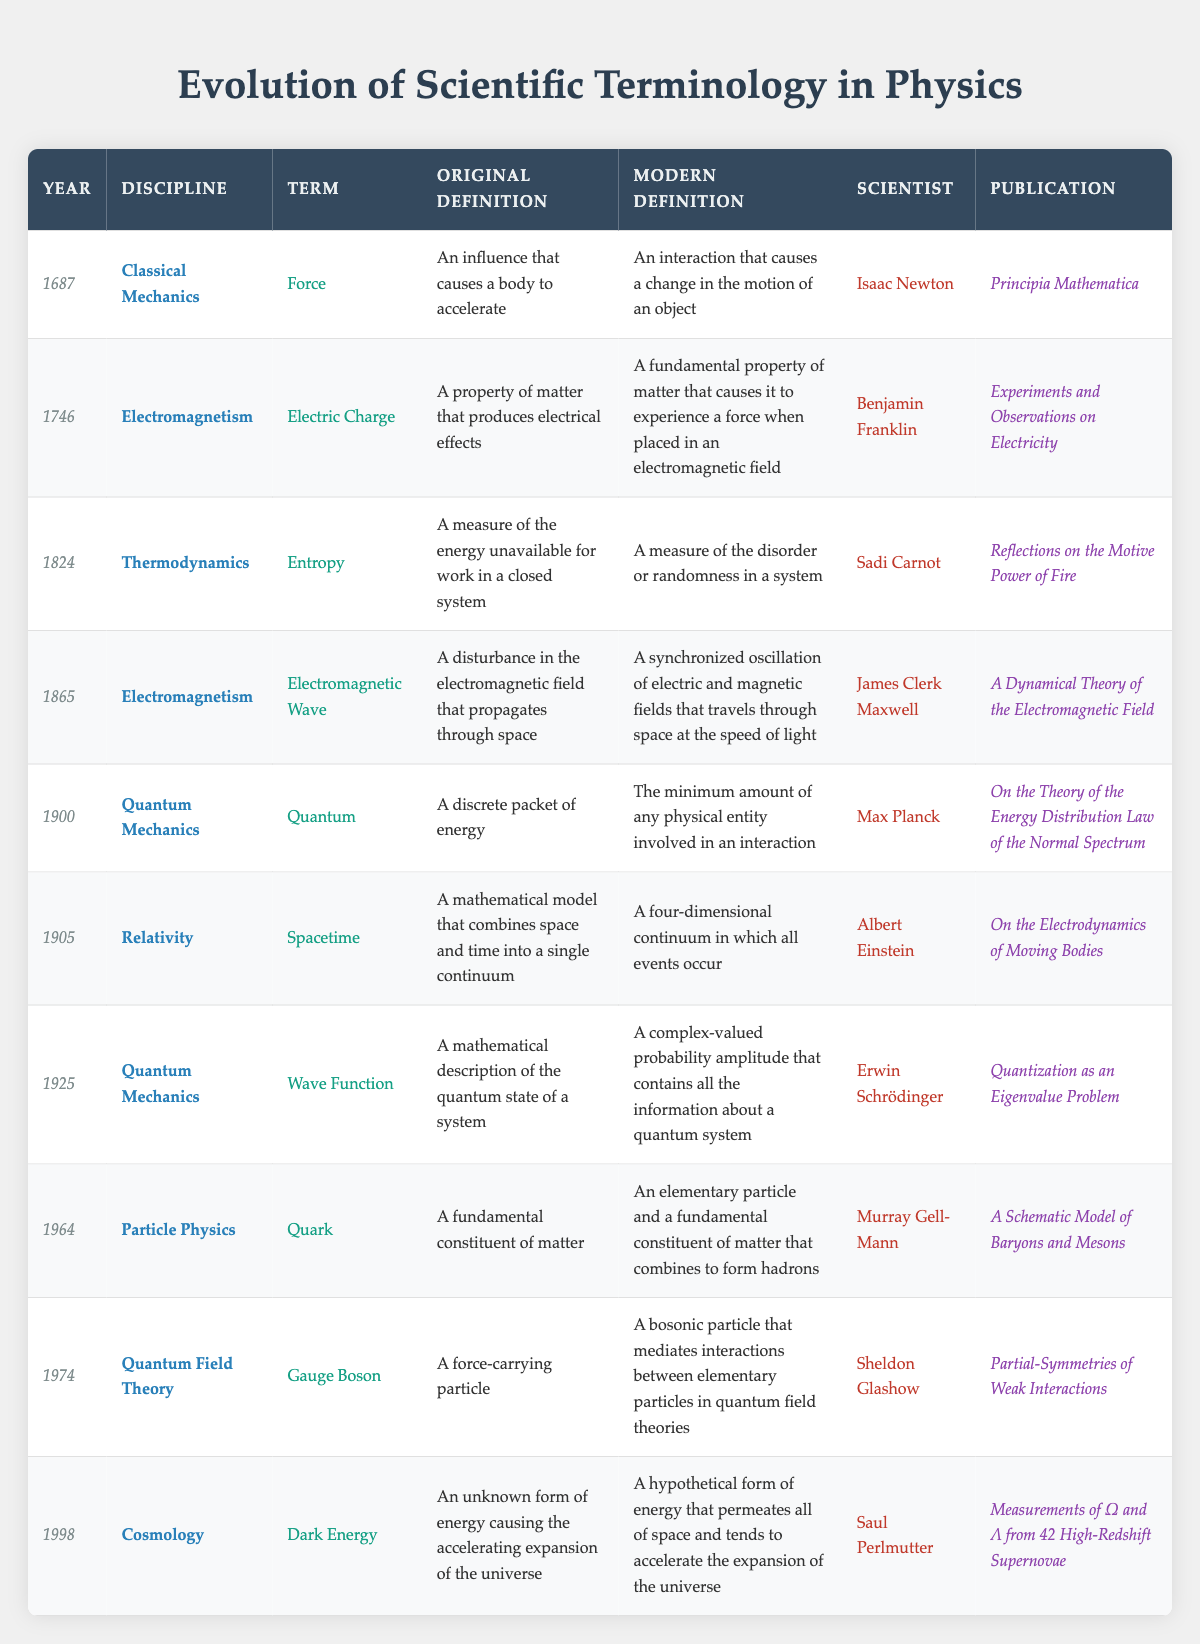What was the original definition of "Force"? The definition of "Force" can be found in the table under the row for the year 1687 and the discipline of Classical Mechanics, which states it as "An influence that causes a body to accelerate".
Answer: An influence that causes a body to accelerate Which scientist published the term "Quantum"? By locating the row for the year 1900 and the discipline of Quantum Mechanics, we identify that Max Planck is the scientist associated with the term "Quantum".
Answer: Max Planck How many terms were defined before the year 1900? To find out how many terms were defined before 1900, we can count the rows with years less than 1900. There are six entries (1687, 1746, 1824, 1865, 1900) before it.
Answer: 5 What is the modern definition of "Dark Energy"? The row corresponding to the year 1998 and the discipline of Cosmology provides the modern definition of "Dark Energy", which states it as "A hypothetical form of energy that permeates all of space and tends to accelerate the expansion of the universe".
Answer: A hypothetical form of energy that permeates all of space and tends to accelerate the expansion of the universe Which term has the most recent definition and who is the associated scientist? The most recent term based on the year column is "Dark Energy" from 1998, associated with Saul Perlmutter.
Answer: Dark Energy, Saul Perlmutter Did Sadi Carnot publish a work related to Quantum Mechanics? To check this, we look at the discipline published by Sadi Carnot, which is listed under Thermodynamics, not Quantum Mechanics. Therefore, the answer is no.
Answer: No What is the average year of publication for the terms listed in Particle Physics and Quantum Field Theory? The years for Particle Physics (Quark, 1964) and Quantum Field Theory (Gauge Boson, 1974) are 1964 and 1974, respectively. Adding these gives 3948, and dividing by 2 yields an average year of 1974.
Answer: 1974 How does the original definition of "Electromagnetic Wave" differ from its modern definition? By examining the row for the term "Electromagnetic Wave" in the table, we see the original definition describes it as "A disturbance in the electromagnetic field that propagates through space", while the modern definition elaborates to "A synchronized oscillation of electric and magnetic fields that travels through space at the speed of light". This shows an evolution from basic description to a more complex understanding involving synchronization and speed.
Answer: It evolved from a basic disturbance to a synchronized oscillation traveling at light speed 